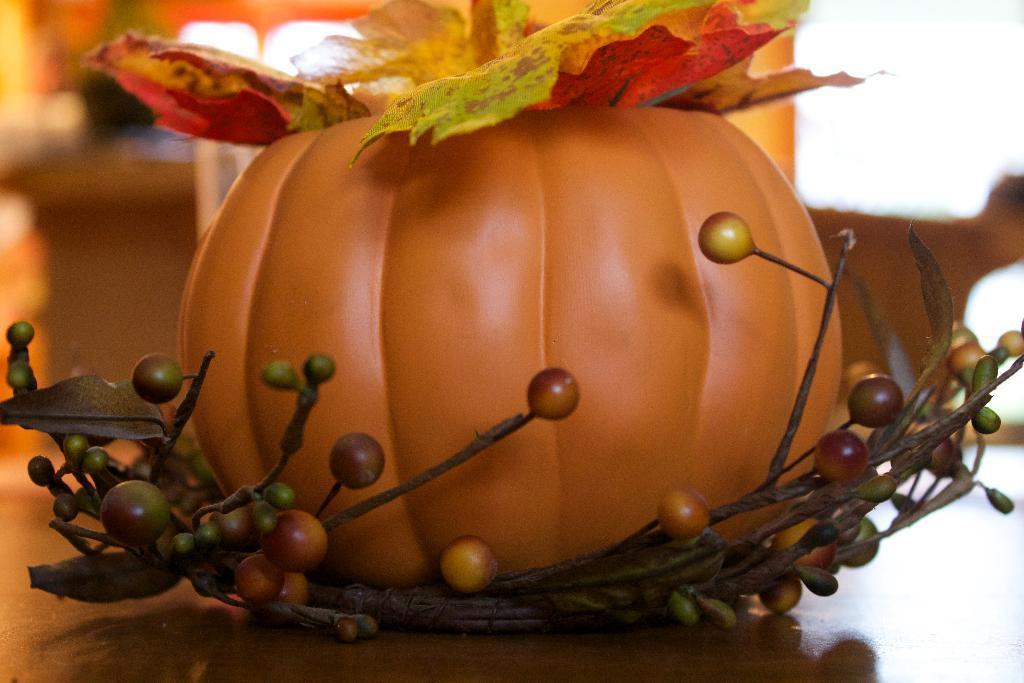Could you give a brief overview of what you see in this image? In the center of this picture we can see some object which seems to be the depiction of a Halloween and we can see some other items placed on the top of the table. In the background we can see a person like thing and some other items. 